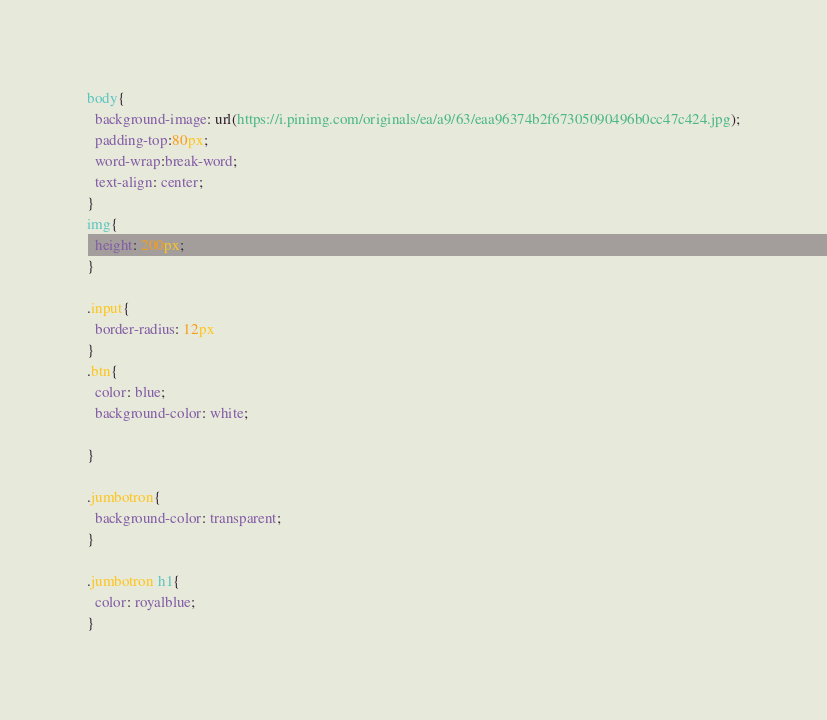<code> <loc_0><loc_0><loc_500><loc_500><_CSS_>body{
  background-image: url(https://i.pinimg.com/originals/ea/a9/63/eaa96374b2f67305090496b0cc47c424.jpg);
  padding-top:80px;
  word-wrap:break-word;
  text-align: center;
}
img{
  height: 200px;
}

.input{
  border-radius: 12px
}
.btn{
  color: blue;
  background-color: white;
 
}

.jumbotron{
  background-color: transparent;
}

.jumbotron h1{
  color: royalblue;
}</code> 